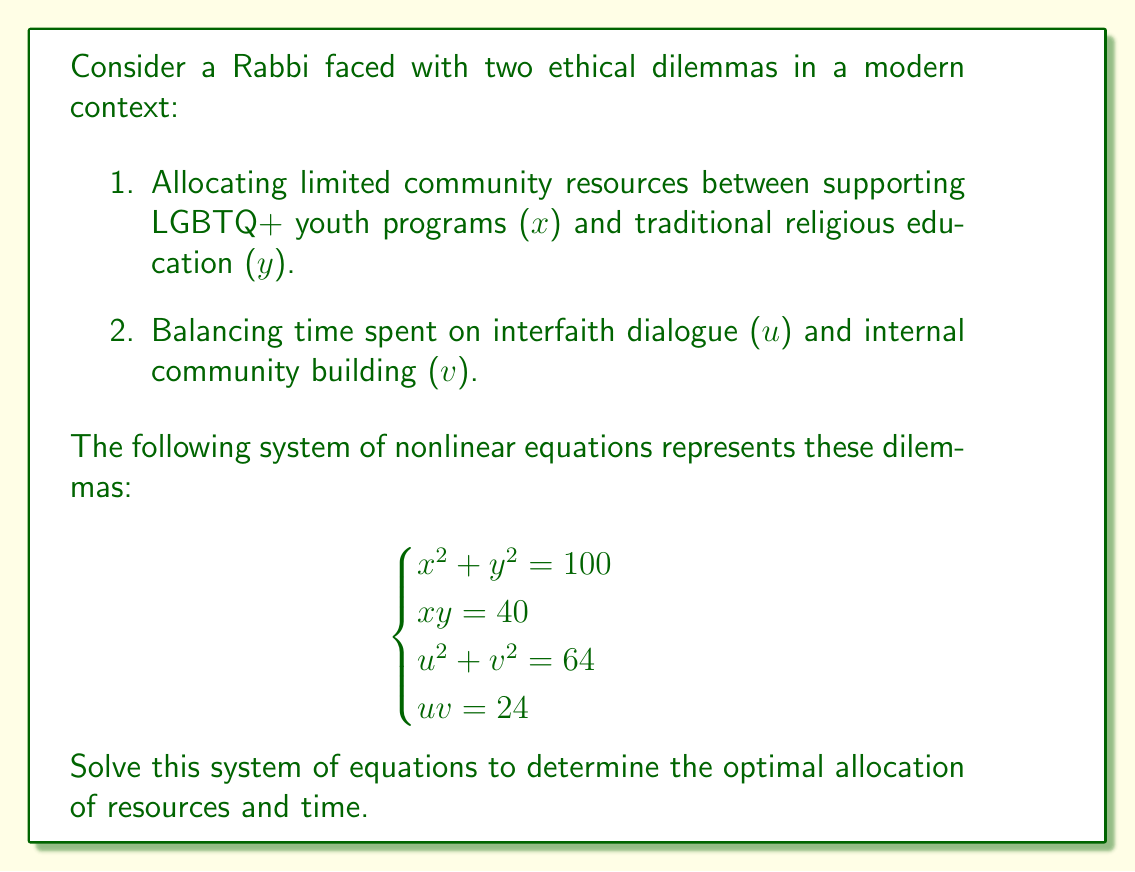What is the answer to this math problem? Let's approach this problem step by step:

1) For the first dilemma (x and y):
   We have two equations: $x^2 + y^2 = 100$ and $xy = 40$

   a) From $xy = 40$, we can express y in terms of x: $y = \frac{40}{x}$
   
   b) Substitute this into the first equation:
      $x^2 + (\frac{40}{x})^2 = 100$
   
   c) Multiply both sides by $x^2$:
      $x^4 + 1600 = 100x^2$
   
   d) Rearrange:
      $x^4 - 100x^2 + 1600 = 0$
   
   e) This is a quadratic in $x^2$. Let $u = x^2$:
      $u^2 - 100u + 1600 = 0$
   
   f) Solve using the quadratic formula:
      $u = \frac{100 \pm \sqrt{10000 - 6400}}{2} = \frac{100 \pm 60}{2}$
   
   g) So, $u = 80$ or $u = 20$
   
   h) Therefore, $x = \sqrt{80} = 4\sqrt{5}$ or $x = \sqrt{20} = 2\sqrt{5}$
   
   i) Since $xy = 40$, when $x = 4\sqrt{5}$, $y = \frac{40}{4\sqrt{5}} = 2\sqrt{5}$
                        when $x = 2\sqrt{5}$, $y = \frac{40}{2\sqrt{5}} = 4\sqrt{5}$

2) For the second dilemma (u and v):
   We have two equations: $u^2 + v^2 = 64$ and $uv = 24$

   The process is similar to the first dilemma:

   a) From $uv = 24$, express v in terms of u: $v = \frac{24}{u}$
   
   b) Substitute into $u^2 + v^2 = 64$:
      $u^2 + (\frac{24}{u})^2 = 64$
   
   c) Multiply by $u^2$:
      $u^4 + 576 = 64u^2$
   
   d) Rearrange:
      $u^4 - 64u^2 + 576 = 0$
   
   e) Let $w = u^2$:
      $w^2 - 64w + 576 = 0$
   
   f) Solve using the quadratic formula:
      $w = \frac{64 \pm \sqrt{4096 - 2304}}{2} = \frac{64 \pm 40}{2}$
   
   g) So, $w = 52$ or $w = 12$
   
   h) Therefore, $u = \sqrt{52} = 2\sqrt{13}$ or $u = \sqrt{12} = 2\sqrt{3}$
   
   i) Since $uv = 24$, when $u = 2\sqrt{13}$, $v = \frac{24}{2\sqrt{13}} = 2\sqrt{3}$
                        when $u = 2\sqrt{3}$, $v = \frac{24}{2\sqrt{3}} = 2\sqrt{13}$
Answer: $(x,y,u,v) = (4\sqrt{5}, 2\sqrt{5}, 2\sqrt{13}, 2\sqrt{3})$ or $(2\sqrt{5}, 4\sqrt{5}, 2\sqrt{3}, 2\sqrt{13})$ 